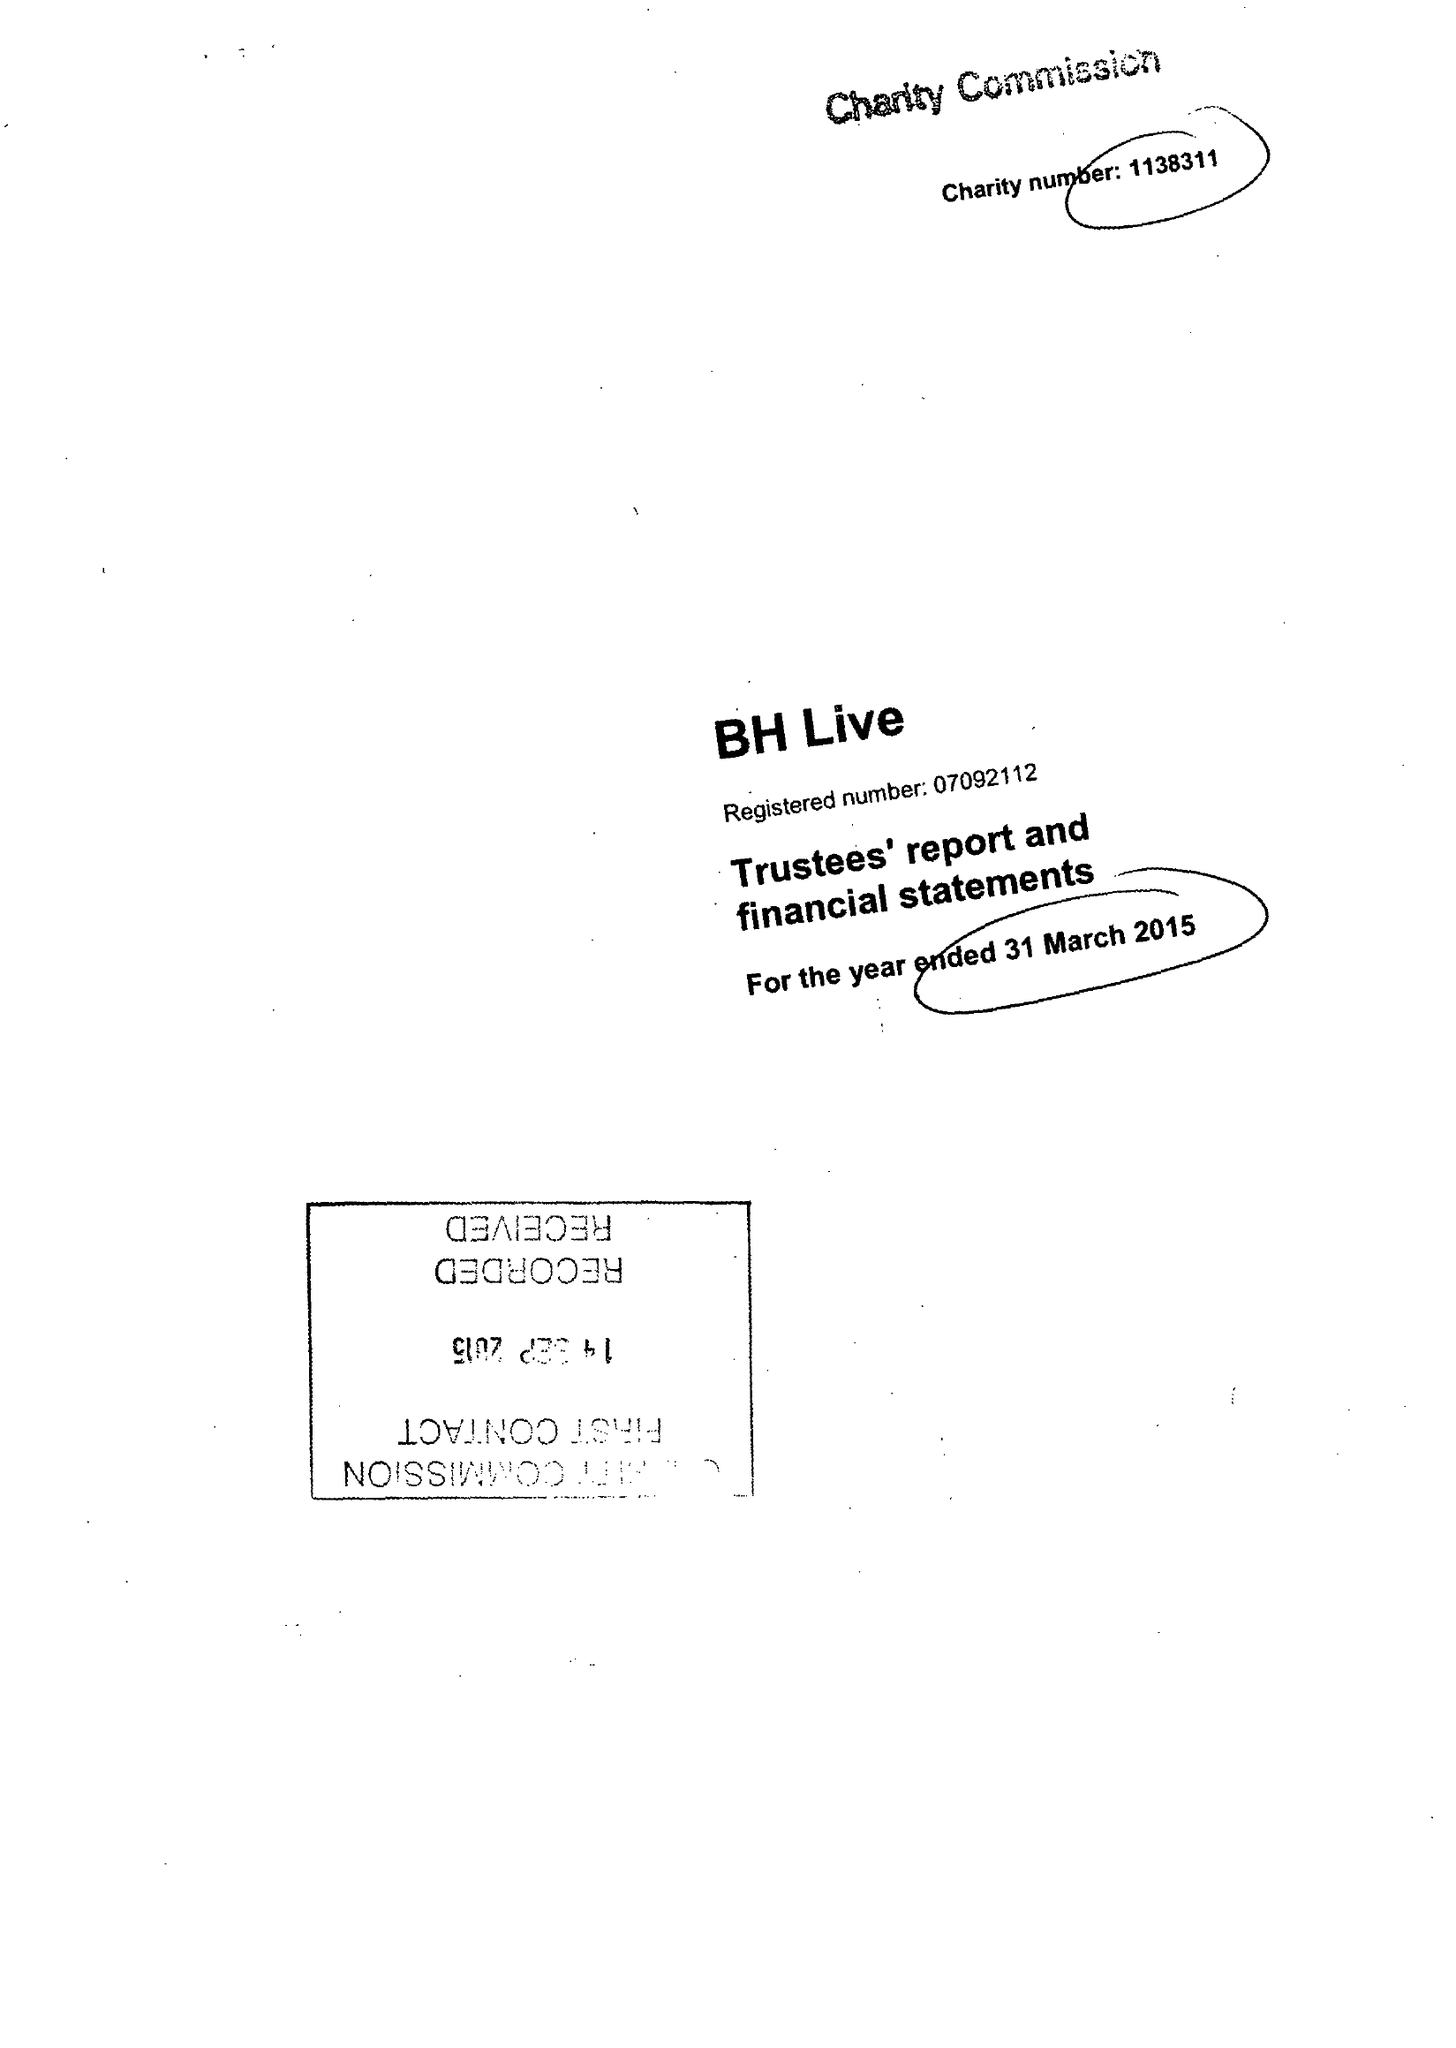What is the value for the report_date?
Answer the question using a single word or phrase. 2015-03-31 